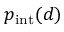<formula> <loc_0><loc_0><loc_500><loc_500>p _ { i n t } ( d )</formula> 